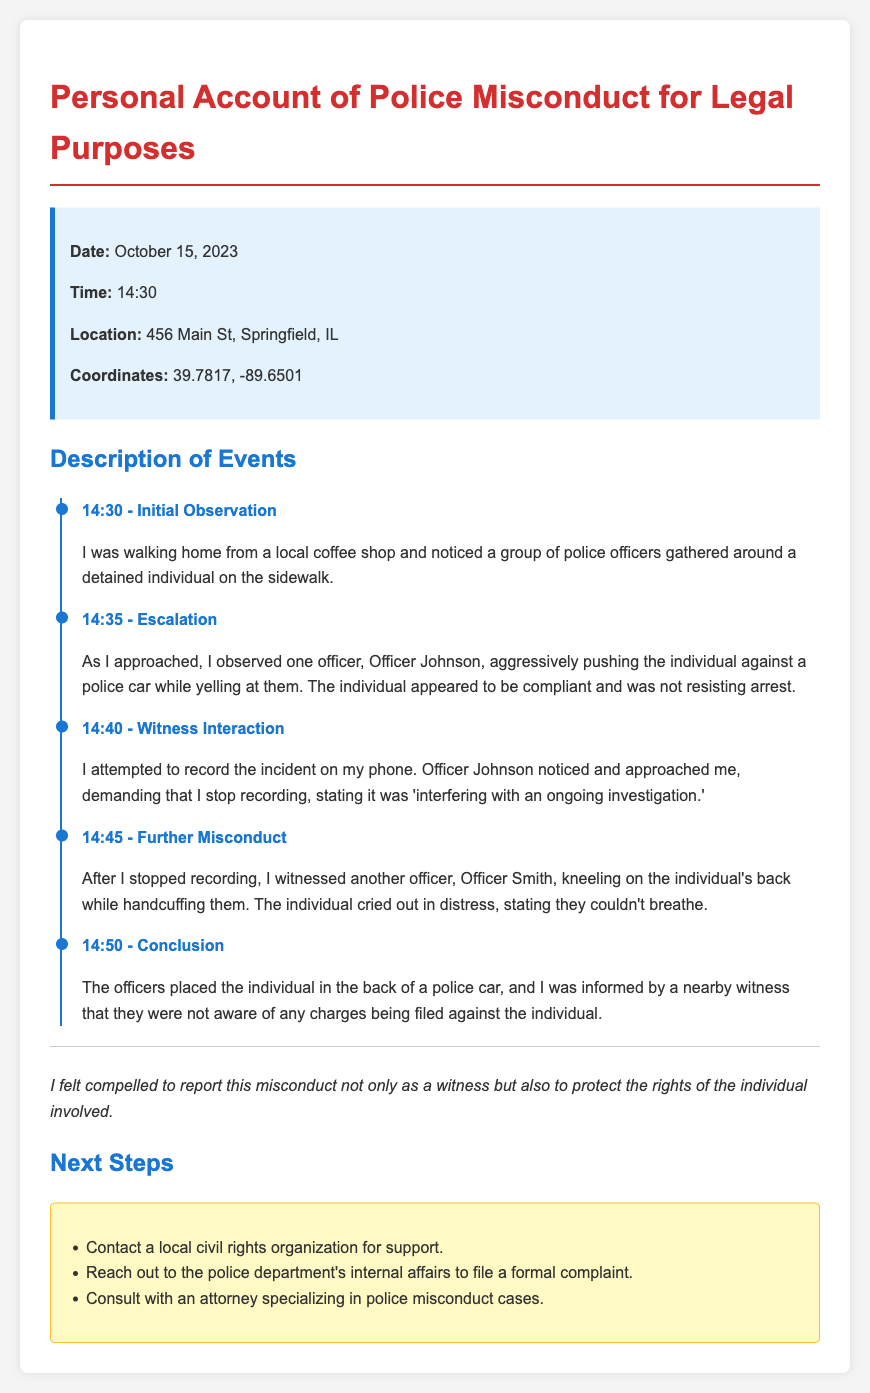What is the date of the incident? The date of the incident is specified in the incident details section, which states October 15, 2023.
Answer: October 15, 2023 What time did the initial observation occur? The time of the initial observation is given as 14:30 in the timeline section.
Answer: 14:30 Where did the incident take place? The location of the incident is mentioned in the incident details, which specifies 456 Main St, Springfield, IL.
Answer: 456 Main St, Springfield, IL What was Officer Johnson doing at 14:35? At 14:35, Officer Johnson was seen aggressively pushing the individual against a police car while yelling.
Answer: Pushing the individual against a police car What did the individual cry out at 14:45? At 14:45, the individual cried out that they couldn't breathe, indicating distress during the incident.
Answer: "I can't breathe" What should be done after witnessing police misconduct? The document outlines next steps to take, which include contacting a local civil rights organization for support.
Answer: Contact a local civil rights organization What is the primary purpose of this memo? The primary purpose of the memo is to document a personal account of police misconduct for legal purposes.
Answer: Document police misconduct How many police officers are mentioned in the memo? The memo explicitly mentions two police officers: Officer Johnson and Officer Smith.
Answer: Two officers What action should be taken regarding the police department? The memo advises reaching out to the police department's internal affairs to file a formal complaint.
Answer: File a formal complaint 